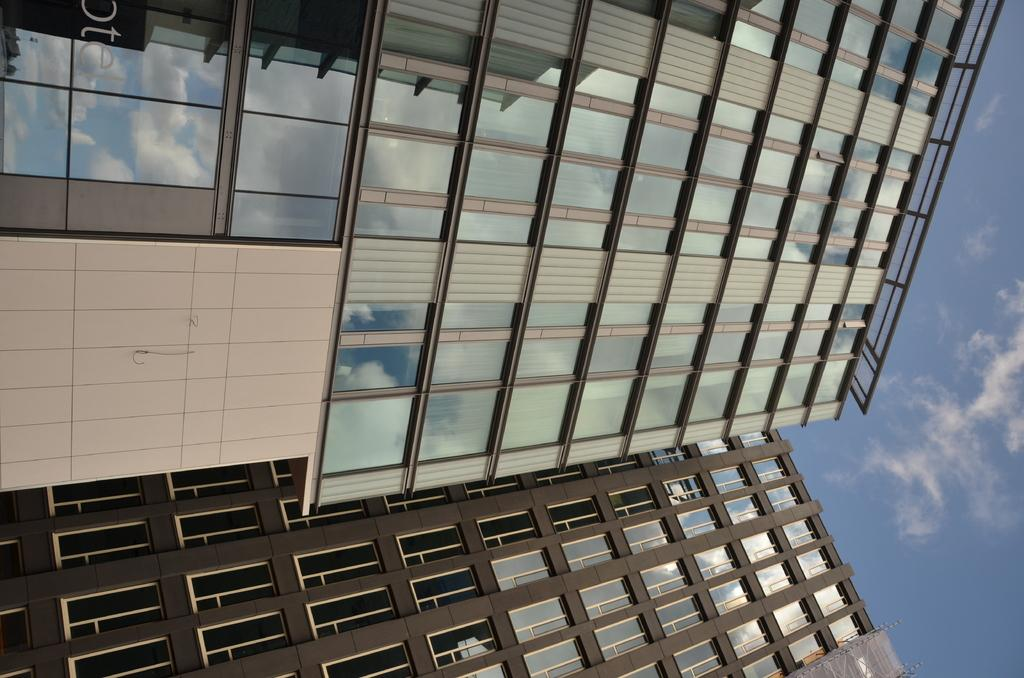What type of building is featured in the image? There is a glass building in the image. What colors can be seen in the sky in the background? The sky in the background is blue and white in color. Where is the goat grazing in the image? There is no goat present in the image. What type of oven is used to cook the food in the image? There is no oven or food present in the image. 